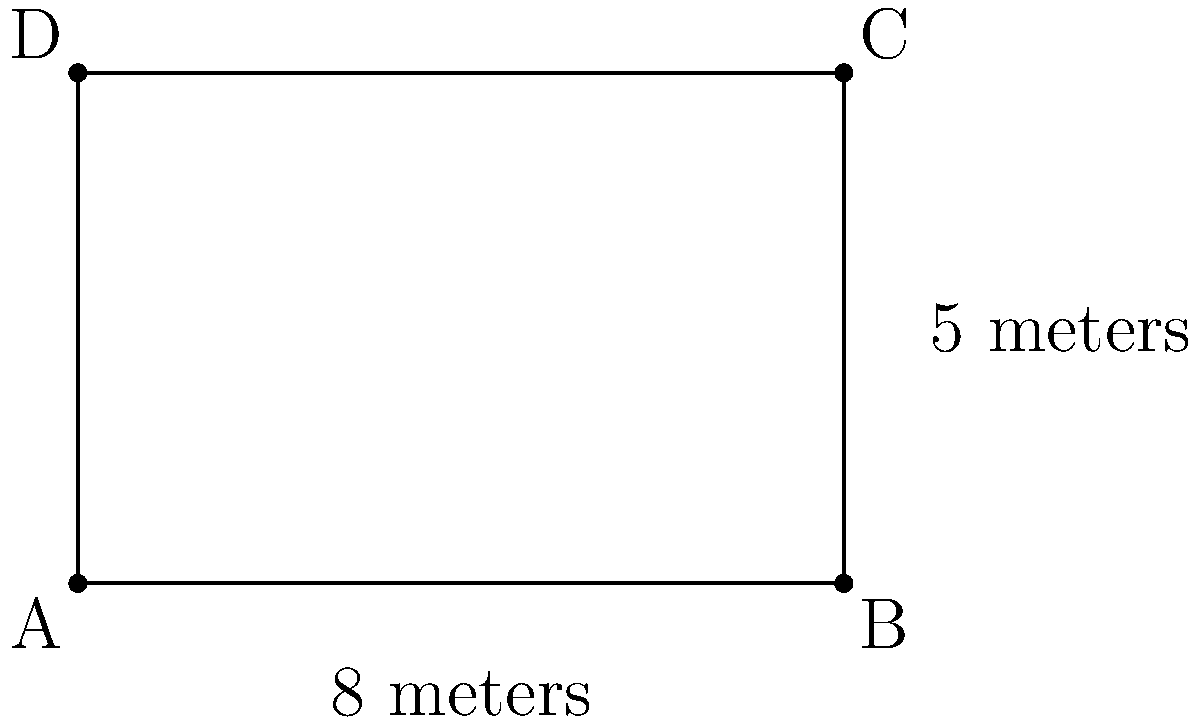Our ancestors built a sacred rectangular stone altar for performing rituals. The altar measures 8 meters in length and 5 meters in width. What is the perimeter of this holy structure? To find the perimeter of the rectangular altar, we need to follow these steps:

1. Recall that the perimeter of a rectangle is the sum of all its sides.
2. In a rectangle, opposite sides are equal in length.
3. The formula for the perimeter of a rectangle is: $P = 2l + 2w$, where $P$ is perimeter, $l$ is length, and $w$ is width.
4. We are given:
   Length ($l$) = 8 meters
   Width ($w$) = 5 meters
5. Let's substitute these values into the formula:
   $P = 2(8) + 2(5)$
6. Simplify:
   $P = 16 + 10 = 26$

Therefore, the perimeter of the sacred stone altar is 26 meters.
Answer: 26 meters 